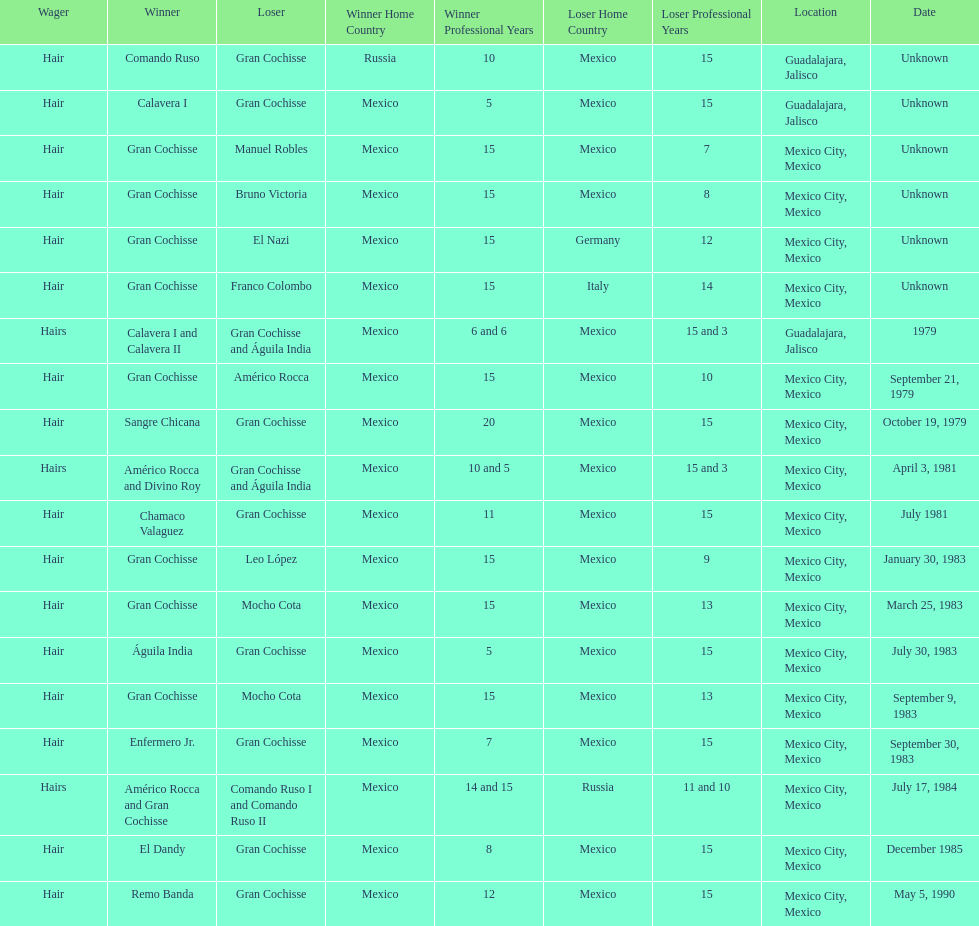How many times has gran cochisse been a winner? 9. 